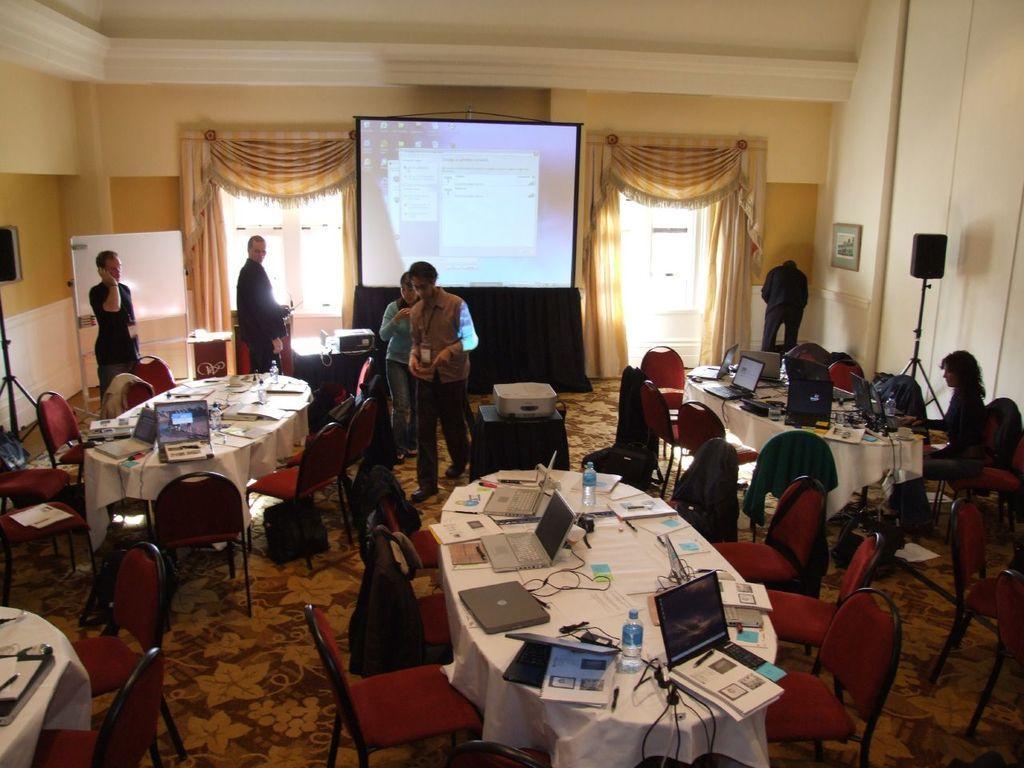Describe this image in one or two sentences. The photo is inside a hall. There are three tables surrounded by chairs. On the table there are laptops,bottles and papers. Few people are standing in the room. One lady on right side is sitting. Beside her there is a speaker. In the background there is a screen two windows with curtains and a white board is there. 